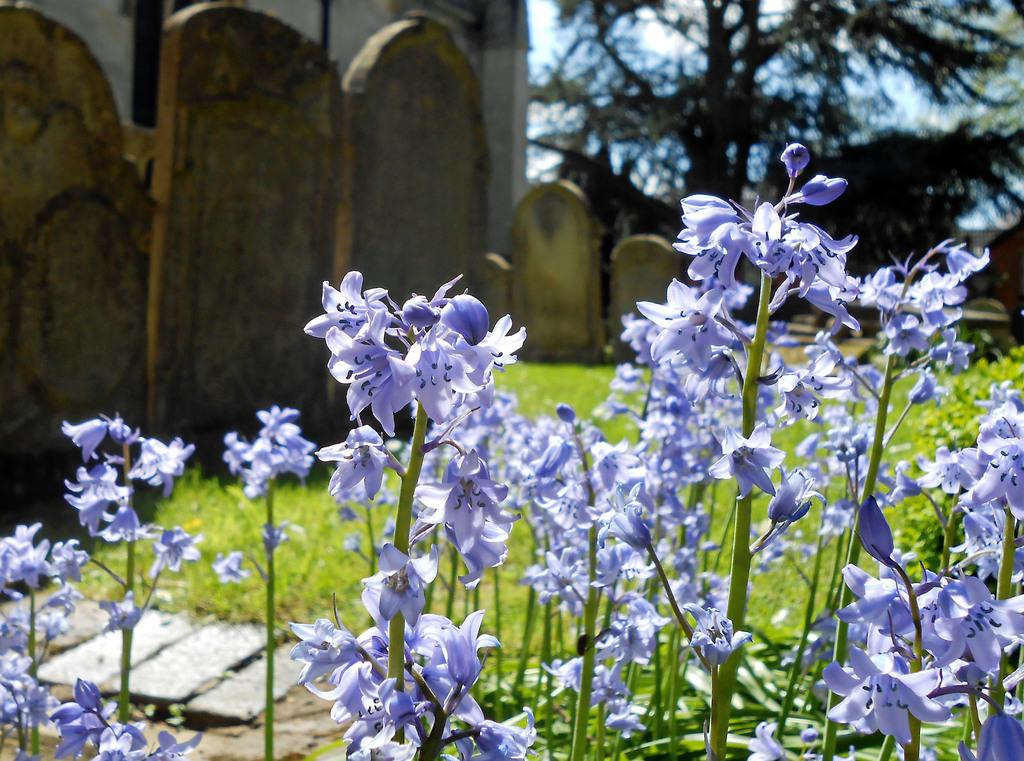What is located in the front of the image? There are flowers and stems in the front of the image. What can be seen in the background of the image? There is grass, memorial stones, and trees in the background of the image. What is visible through the trees in the background? The sky is visible through the trees in the background. What type of brass instrument is being played by the trees in the background? There is no brass instrument present in the image; the trees are not playing any musical instruments. What message of love can be seen on the memorial stones in the background? There is no message of love visible on the memorial stones in the image; the stones are not inscribed with any text. 